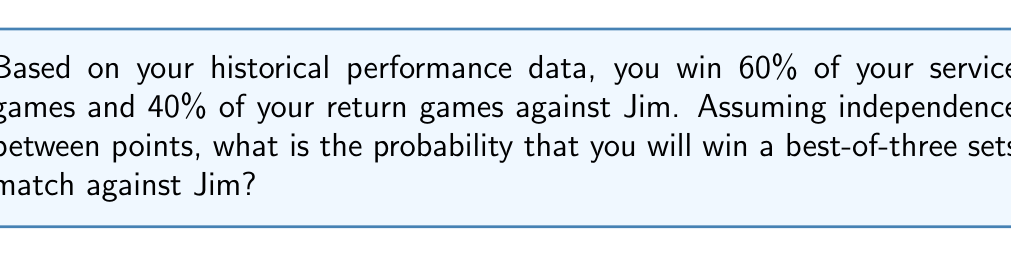Give your solution to this math problem. To solve this problem, we need to follow these steps:

1) First, calculate the probability of winning a single set. A set is won when a player wins at least 6 games and has a 2-game lead.

2) Let's define:
   $p_s$ = probability of winning a service game = 0.60
   $p_r$ = probability of winning a return game = 0.40

3) The probability of winning a set can be approximated using the formula:

   $$P(\text{win set}) = \sum_{k=6}^{\infty} \binom{2k-1}{k} p_s^k p_r^{k-1} (1-p_s)^{k-1} (1-p_r)^k$$

4) Using a computer to calculate this sum (as it's an infinite series), we get:
   $P(\text{win set}) \approx 0.7138$

5) Now, to win a best-of-three sets match, you need to win either:
   - The first two sets, OR
   - The first and third sets, OR
   - The second and third sets

6) The probability of each scenario:
   - Win first two sets: $0.7138 * 0.7138 = 0.5095$
   - Win first and third sets: $0.7138 * (1-0.7138) * 0.7138 = 0.1459$
   - Win second and third sets: $(1-0.7138) * 0.7138 * 0.7138 = 0.1459$

7) The total probability of winning the match is the sum of these probabilities:

   $$P(\text{win match}) = 0.5095 + 0.1459 + 0.1459 = 0.8013$$

Therefore, the probability of winning the best-of-three sets match against Jim is approximately 0.8013 or 80.13%.
Answer: 0.8013 